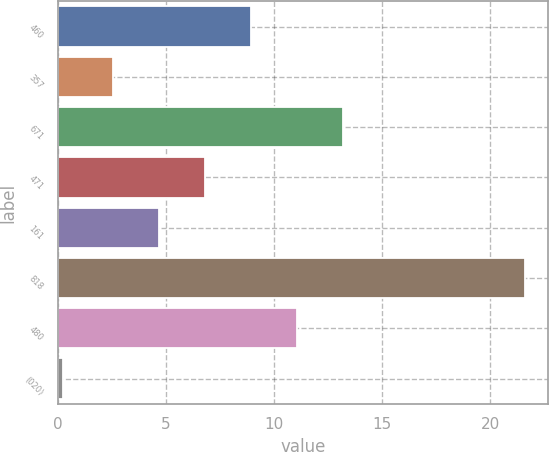<chart> <loc_0><loc_0><loc_500><loc_500><bar_chart><fcel>460<fcel>357<fcel>671<fcel>471<fcel>161<fcel>818<fcel>480<fcel>(020)<nl><fcel>8.93<fcel>2.54<fcel>13.19<fcel>6.8<fcel>4.67<fcel>21.59<fcel>11.06<fcel>0.25<nl></chart> 